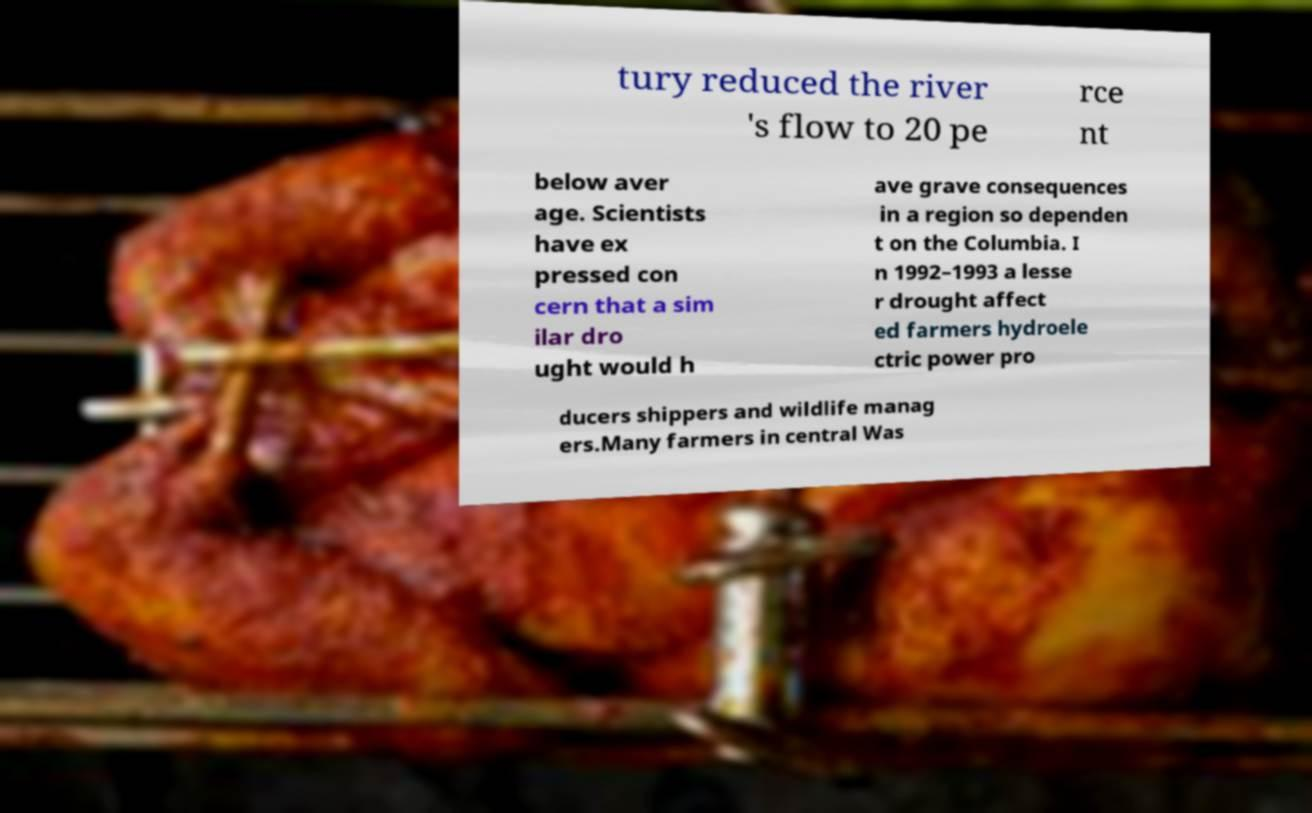Can you accurately transcribe the text from the provided image for me? tury reduced the river 's flow to 20 pe rce nt below aver age. Scientists have ex pressed con cern that a sim ilar dro ught would h ave grave consequences in a region so dependen t on the Columbia. I n 1992–1993 a lesse r drought affect ed farmers hydroele ctric power pro ducers shippers and wildlife manag ers.Many farmers in central Was 